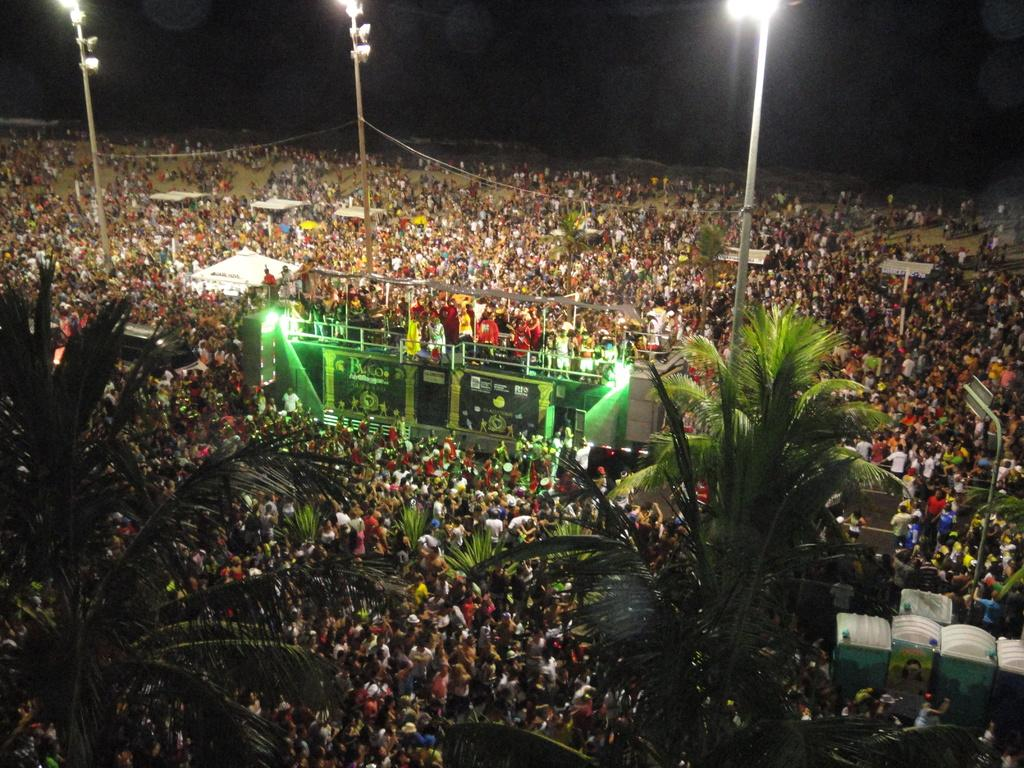What is happening in the image involving a group of people? There is a group of people standing in the image. What type of vegetation is present in the image? There are trees in the image, and they are green in color. What structures can be seen in the image? There are light poles and a stage in the image. How would you describe the lighting in the image? The background of the image is dark. What type of yarn is being used to decorate the trees in the image? There is no yarn present in the image; the trees are simply green in color. Is there a house visible in the image? No, there is no house present in the image. 